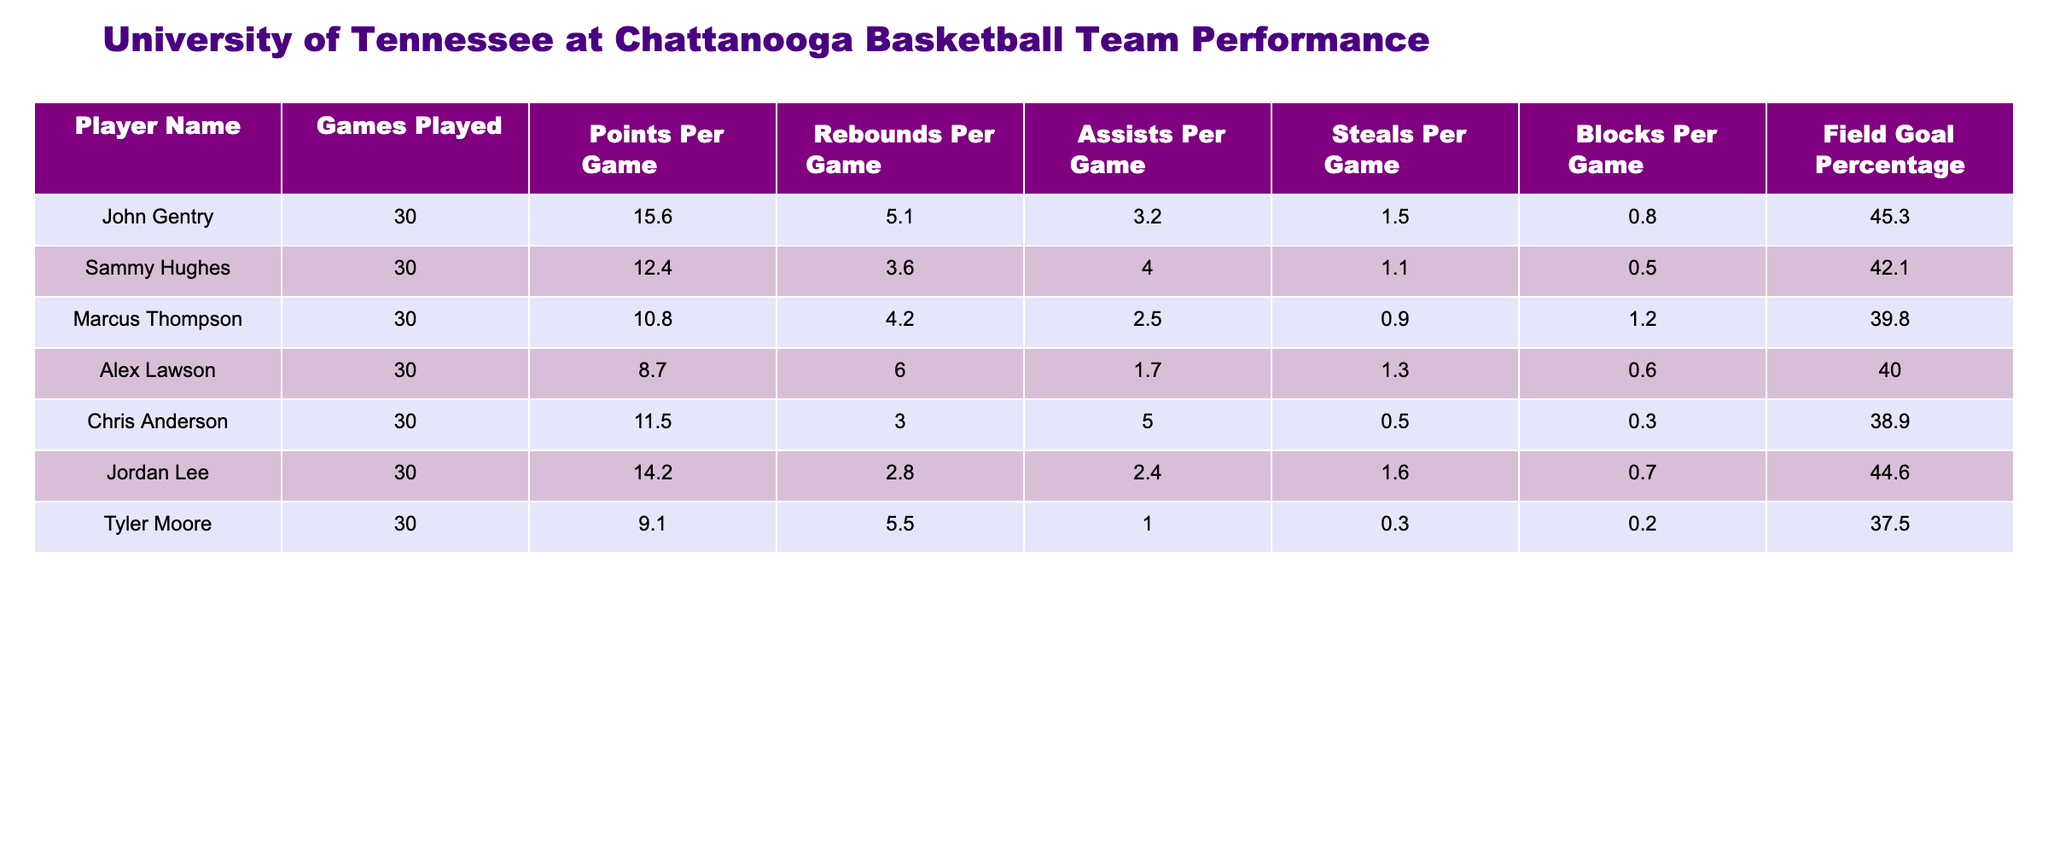What is the highest Points Per Game among the players? Looking through the "Points Per Game" column, John Gentry has the highest value at 15.6.
Answer: 15.6 What is the average number of Rebounds Per Game for the team? To find the average, sum the rebounds: (5.1 + 3.6 + 4.2 + 6.0 + 3.0 + 2.8 + 5.5) = 30.2. There are 7 players, so the average is 30.2 / 7 = 4.31.
Answer: 4.31 Did any player have a Blocks Per Game value greater than 1? By examining the "Blocks Per Game" column, only Marcus Thompson has a value of 1.2, which is greater than 1.
Answer: Yes Which player has the lowest Field Goal Percentage? In the "Field Goal Percentage" column, Tyler Moore has the lowest value at 37.5.
Answer: 37.5 What is the total number of Assists Per Game for all players? To find the total assists, add the assists: (3.2 + 4.0 + 2.5 + 1.7 + 5.0 + 2.4 + 1.0) = 20.8.
Answer: 20.8 Is John Gentry the player with the most Rebounds Per Game? Checking the "Rebounds Per Game" column, Alex Lawson has the highest value (6.0), which is greater than John Gentry's 5.1.
Answer: No What percentage of players average more than 10 Points Per Game? From the player list, John Gentry, Sammy Hughes, and Jordan Lee average more than 10, totaling 3 players. The total count is 7, so the percentage is (3 / 7) * 100 = 42.86%.
Answer: 42.86% What is the difference between the highest and lowest Points Per Game? The highest is John Gentry at 15.6 and the lowest is Marcus Thompson at 10.8. The difference is 15.6 - 10.8 = 4.8.
Answer: 4.8 Which player has the second highest average Steals Per Game? The players sorted by "Steals Per Game" show that after John Gentry (1.5), Jordan Lee has the second highest value at 1.6.
Answer: Jordan Lee 